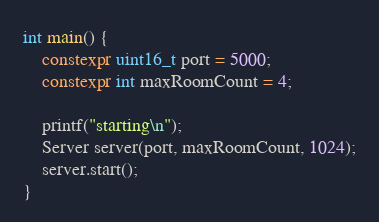<code> <loc_0><loc_0><loc_500><loc_500><_C++_>
int main() {
    constexpr uint16_t port = 5000;
    constexpr int maxRoomCount = 4;

    printf("starting\n");
    Server server(port, maxRoomCount, 1024);
    server.start();
}</code> 